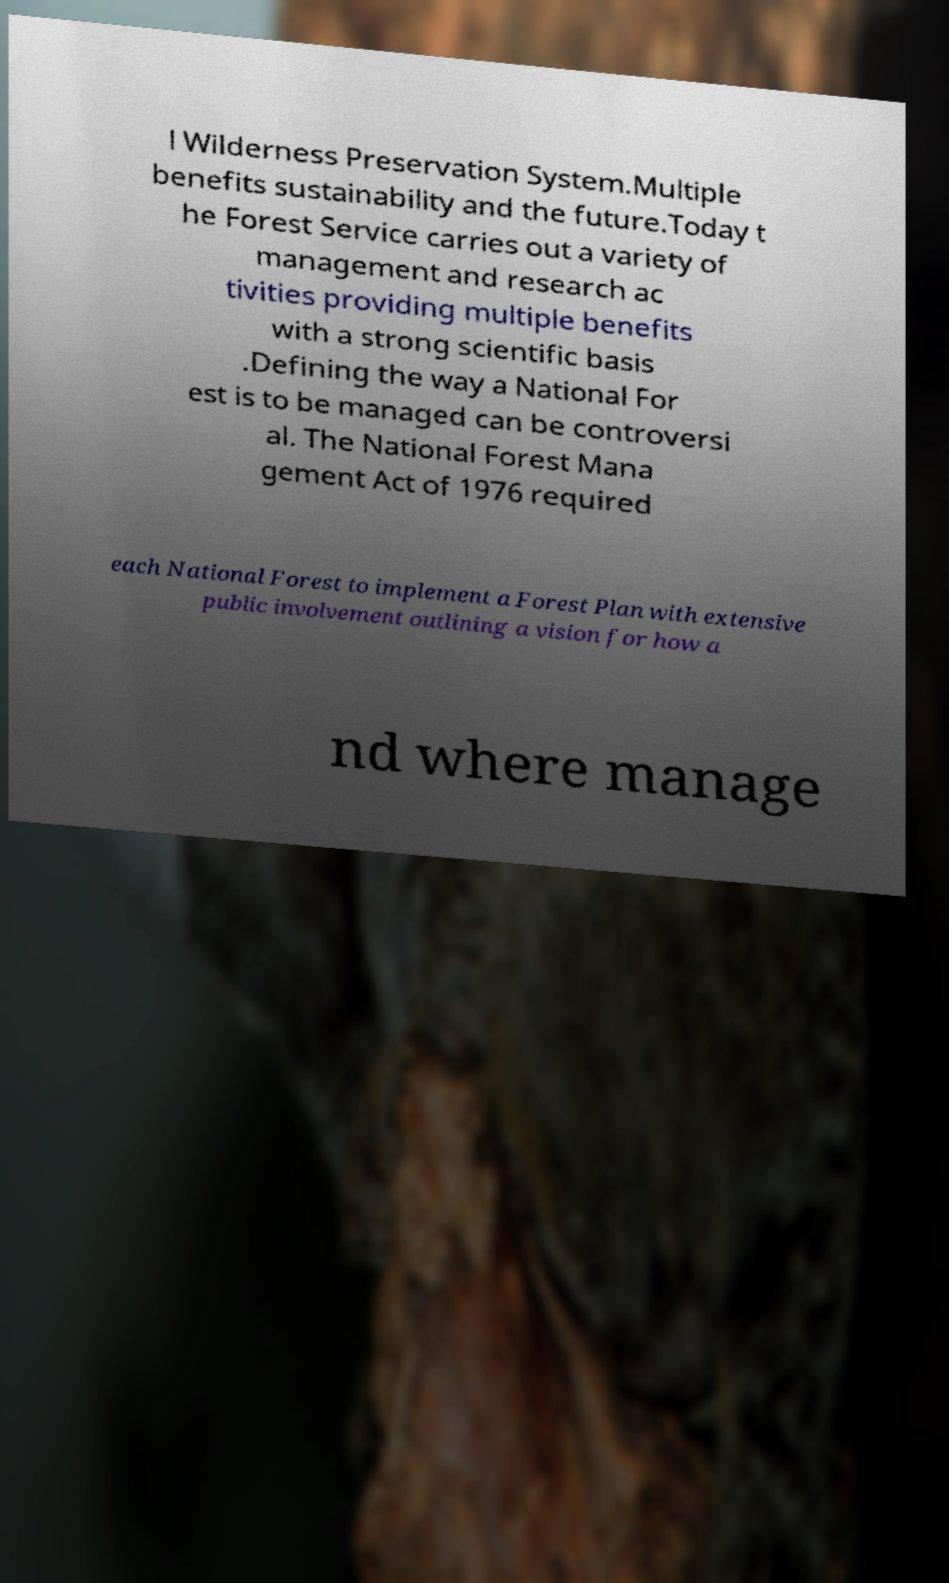I need the written content from this picture converted into text. Can you do that? l Wilderness Preservation System.Multiple benefits sustainability and the future.Today t he Forest Service carries out a variety of management and research ac tivities providing multiple benefits with a strong scientific basis .Defining the way a National For est is to be managed can be controversi al. The National Forest Mana gement Act of 1976 required each National Forest to implement a Forest Plan with extensive public involvement outlining a vision for how a nd where manage 